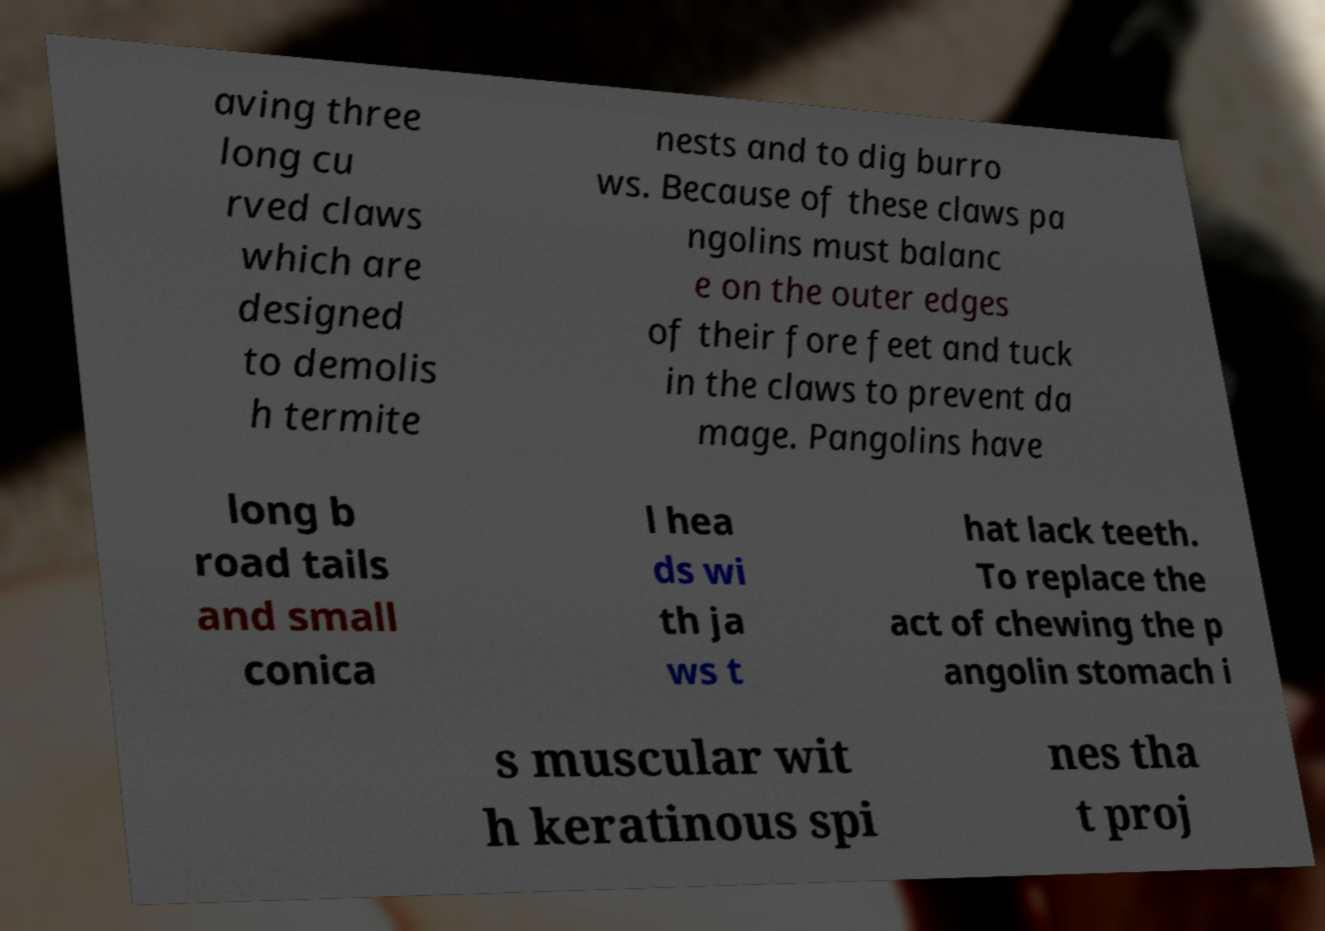Could you assist in decoding the text presented in this image and type it out clearly? aving three long cu rved claws which are designed to demolis h termite nests and to dig burro ws. Because of these claws pa ngolins must balanc e on the outer edges of their fore feet and tuck in the claws to prevent da mage. Pangolins have long b road tails and small conica l hea ds wi th ja ws t hat lack teeth. To replace the act of chewing the p angolin stomach i s muscular wit h keratinous spi nes tha t proj 